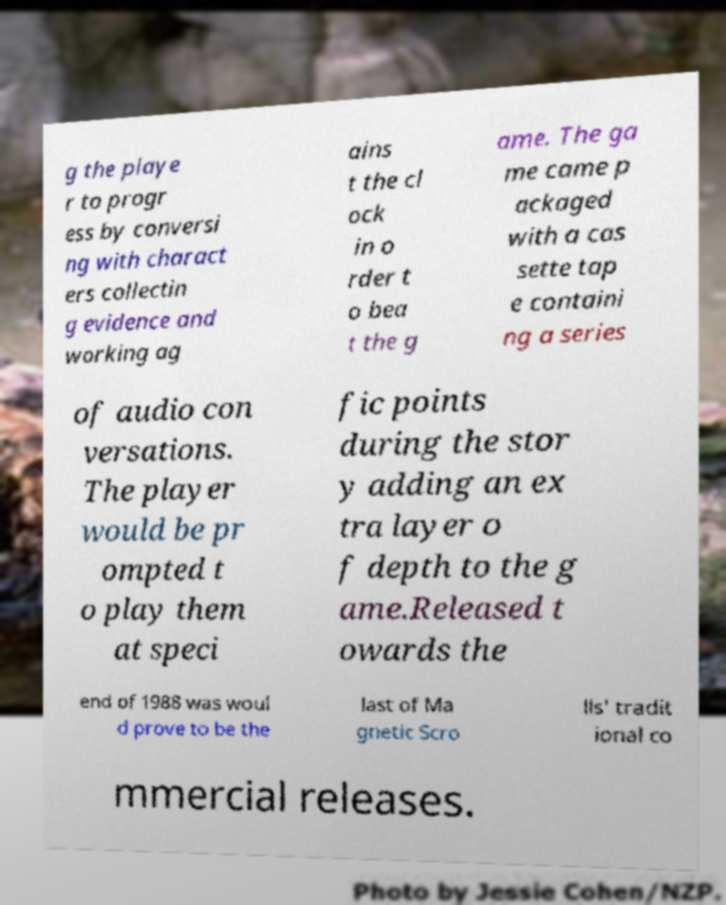Please identify and transcribe the text found in this image. g the playe r to progr ess by conversi ng with charact ers collectin g evidence and working ag ains t the cl ock in o rder t o bea t the g ame. The ga me came p ackaged with a cas sette tap e containi ng a series of audio con versations. The player would be pr ompted t o play them at speci fic points during the stor y adding an ex tra layer o f depth to the g ame.Released t owards the end of 1988 was woul d prove to be the last of Ma gnetic Scro lls' tradit ional co mmercial releases. 